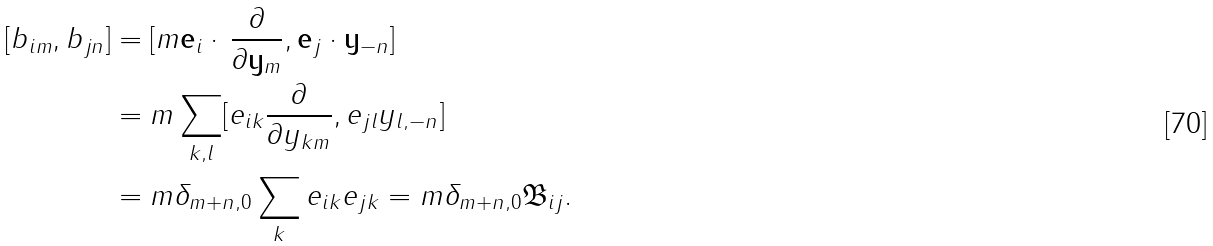Convert formula to latex. <formula><loc_0><loc_0><loc_500><loc_500>[ b _ { i m } , b _ { j n } ] & = [ m \mathbf e _ { i } \cdot \, \frac { \partial } { \partial \mathbf y _ { m } } , \mathbf e _ { j } \cdot \mathbf y _ { - n } ] \\ & = m \sum _ { k , l } [ e _ { i k } \frac { \partial } { \partial y _ { k m } } , e _ { j l } y _ { l , - n } ] \\ & = m \delta _ { m + n , 0 } \sum _ { k } e _ { i k } e _ { j k } = m \delta _ { m + n , 0 } \mathfrak B _ { i j } .</formula> 